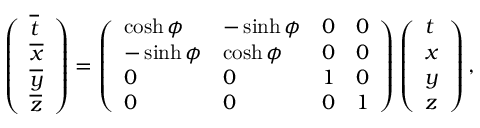<formula> <loc_0><loc_0><loc_500><loc_500>\left ( \begin{array} { l } { \overline { t } } \\ { \overline { x } } \\ { \overline { y } } \\ { \overline { z } } \end{array} \right ) = \left ( \begin{array} { l l l l } { \cosh \phi } & { - \sinh \phi } & { 0 } & { 0 } \\ { - \sinh \phi } & { \cosh \phi } & { 0 } & { 0 } \\ { 0 } & { 0 } & { 1 } & { 0 } \\ { 0 } & { 0 } & { 0 } & { 1 } \end{array} \right ) \left ( \begin{array} { l } { t } \\ { x } \\ { y } \\ { z } \end{array} \right ) ,</formula> 